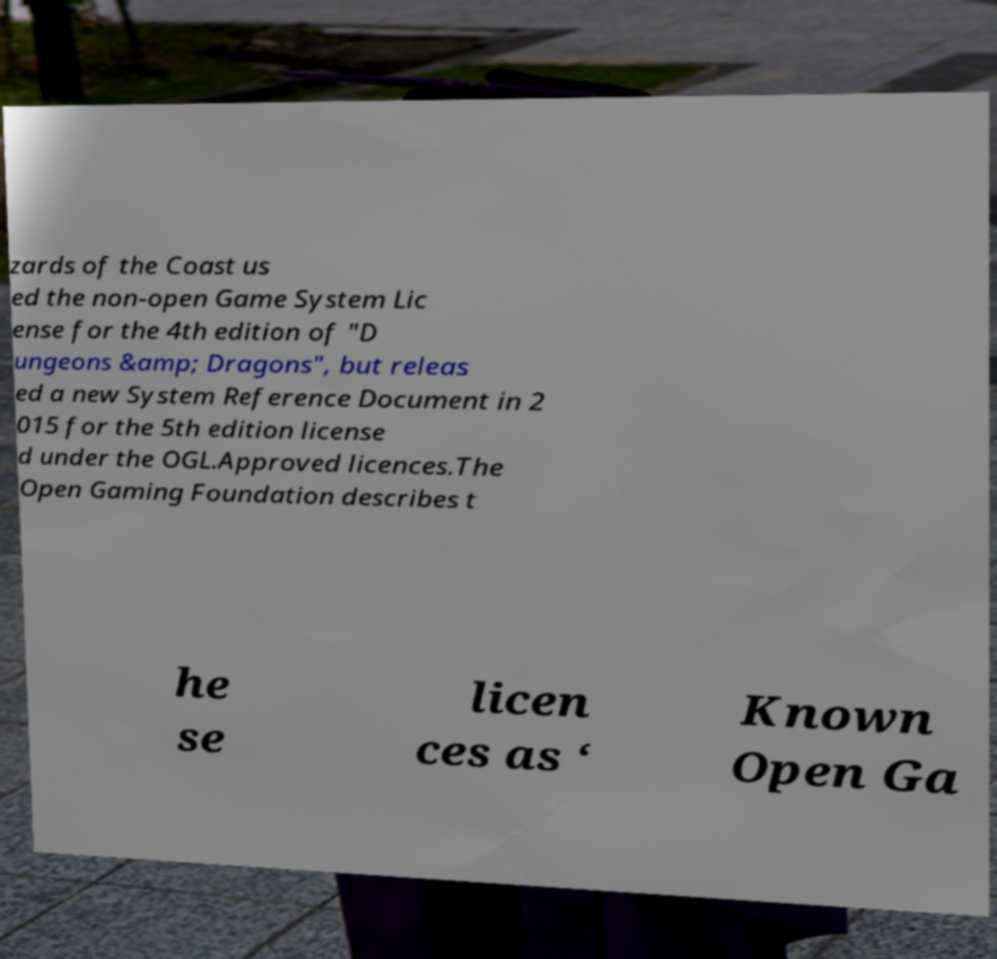Please identify and transcribe the text found in this image. zards of the Coast us ed the non-open Game System Lic ense for the 4th edition of "D ungeons &amp; Dragons", but releas ed a new System Reference Document in 2 015 for the 5th edition license d under the OGL.Approved licences.The Open Gaming Foundation describes t he se licen ces as ‘ Known Open Ga 